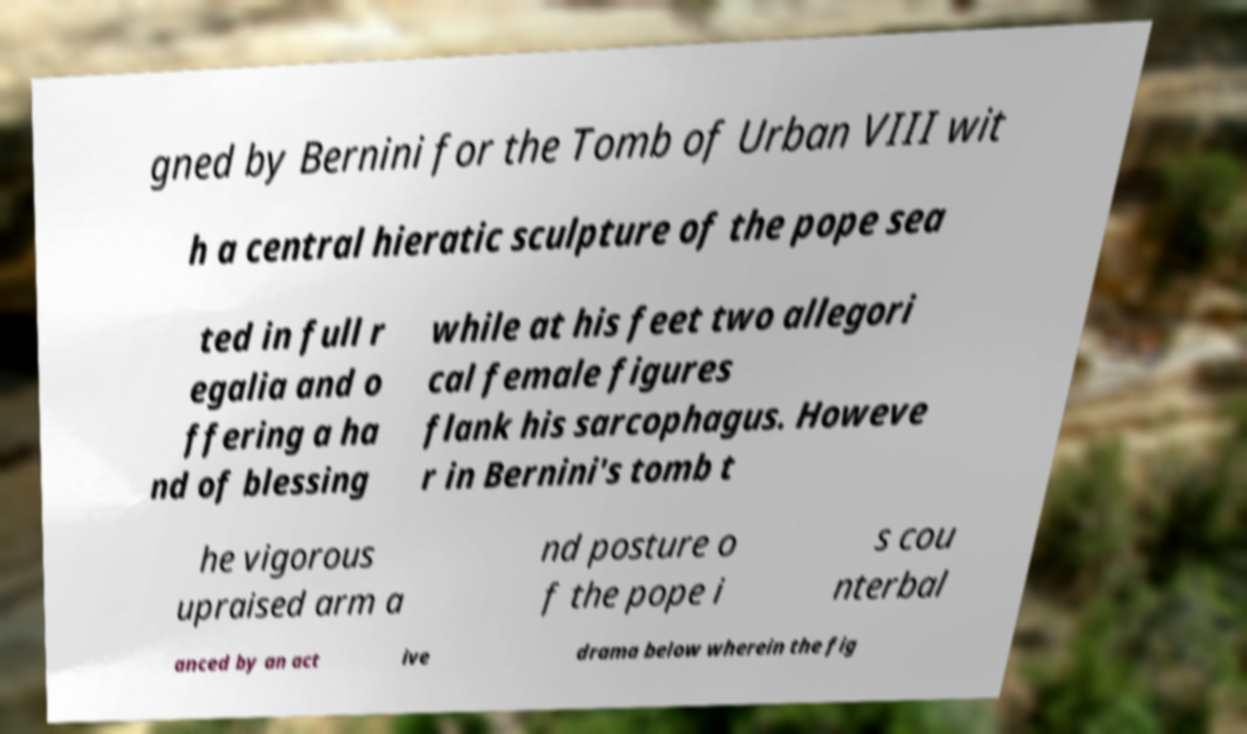Can you accurately transcribe the text from the provided image for me? gned by Bernini for the Tomb of Urban VIII wit h a central hieratic sculpture of the pope sea ted in full r egalia and o ffering a ha nd of blessing while at his feet two allegori cal female figures flank his sarcophagus. Howeve r in Bernini's tomb t he vigorous upraised arm a nd posture o f the pope i s cou nterbal anced by an act ive drama below wherein the fig 